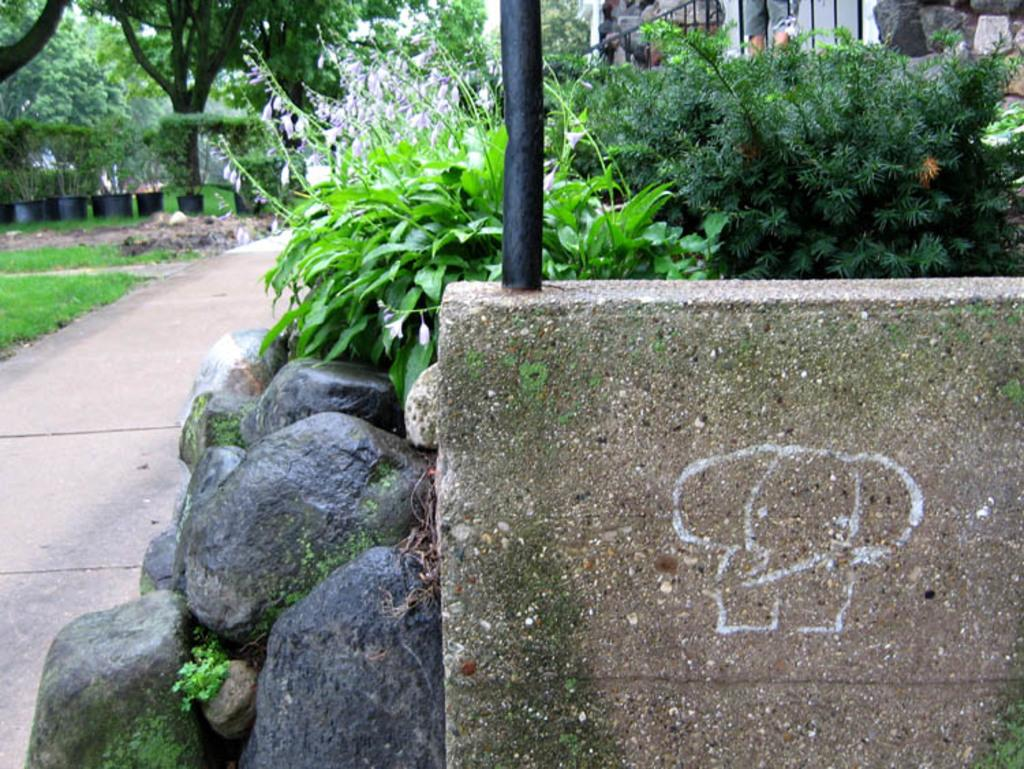What type of objects can be seen on the ground in the image? There are stones in the image. What structure is visible in the image? There is a wall in the image. What can be seen in the background of the image? There are plants, trees, and a building in the background of the image. What is the person in the image doing? The information provided does not specify what the person is doing. What type of surface is visible in the image? There is a path in the image. What type of bag is the person carrying on their head in the image? There is no person carrying a bag on their head in the image. What type of coil is wrapped around the trees in the background of the image? There is no coil present in the image; only trees, plants, and a building are visible in the background. 